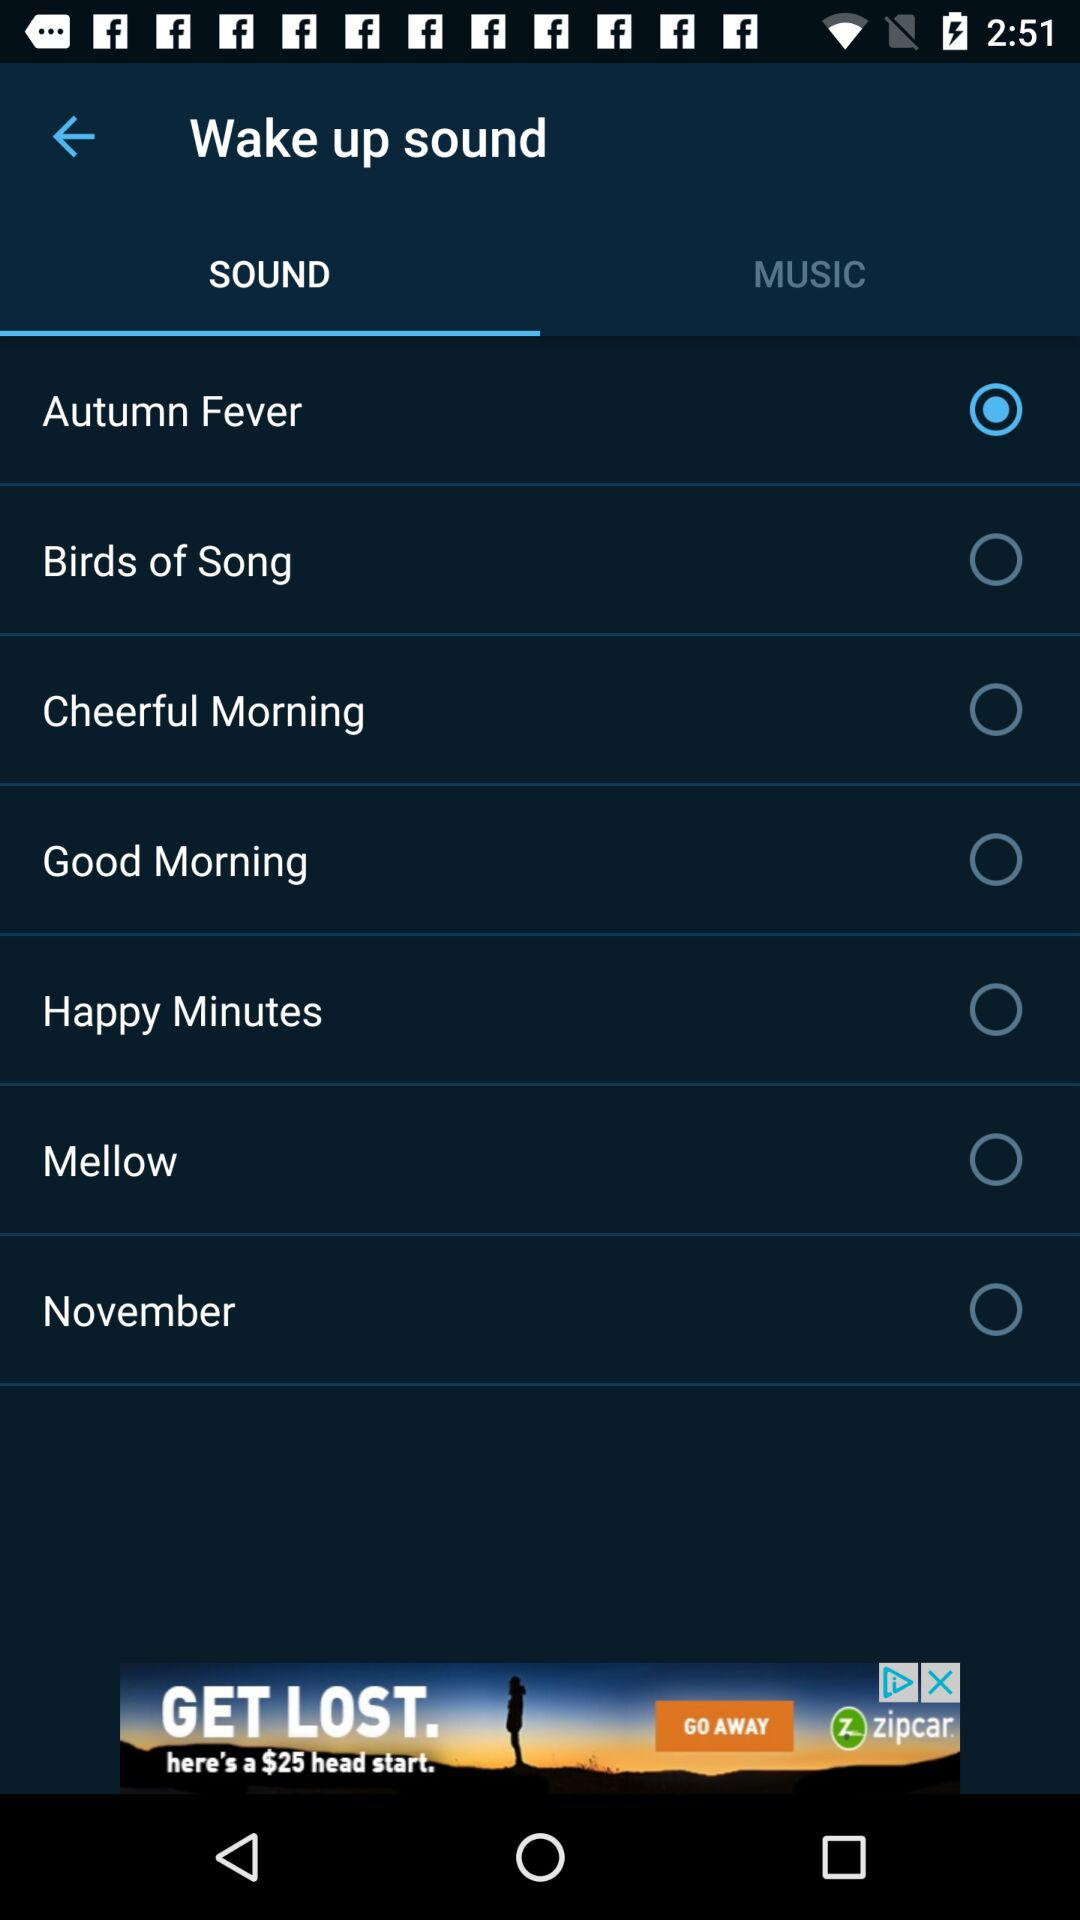What is the selected option in "Wake up sound"? The selected options in "Wake up sound" are "SOUND" and "Autumn Fever". 